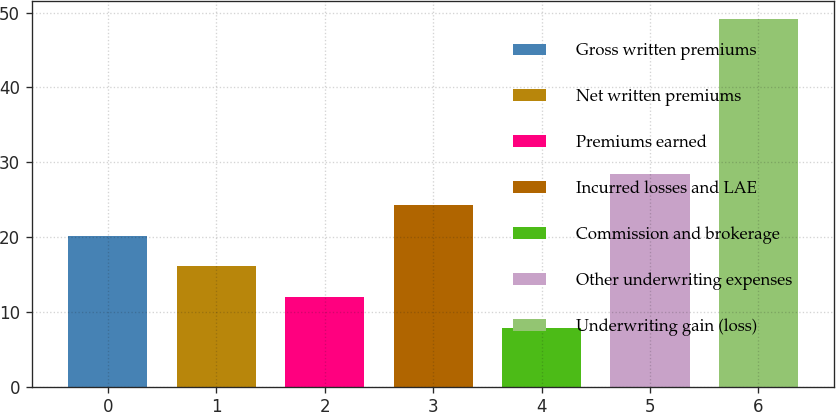<chart> <loc_0><loc_0><loc_500><loc_500><bar_chart><fcel>Gross written premiums<fcel>Net written premiums<fcel>Premiums earned<fcel>Incurred losses and LAE<fcel>Commission and brokerage<fcel>Other underwriting expenses<fcel>Underwriting gain (loss)<nl><fcel>20.19<fcel>16.06<fcel>11.93<fcel>24.32<fcel>7.8<fcel>28.45<fcel>49.1<nl></chart> 